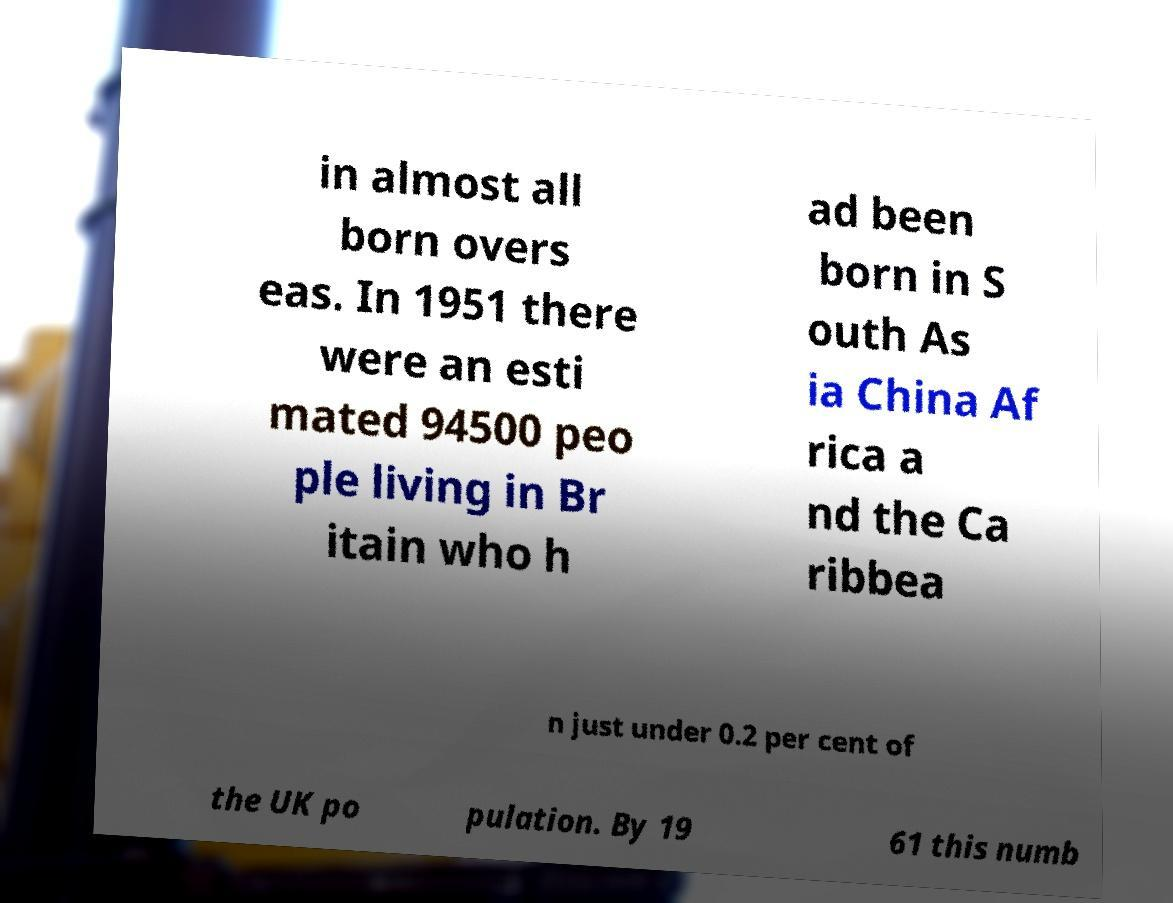Could you assist in decoding the text presented in this image and type it out clearly? in almost all born overs eas. In 1951 there were an esti mated 94500 peo ple living in Br itain who h ad been born in S outh As ia China Af rica a nd the Ca ribbea n just under 0.2 per cent of the UK po pulation. By 19 61 this numb 